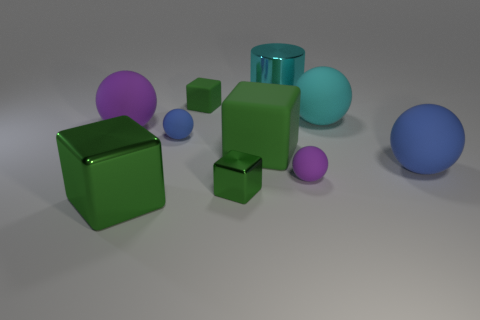Does the blue matte sphere that is left of the large cyan rubber ball have the same size as the cyan object on the right side of the cyan shiny cylinder? The two objects you're referring to are indeed distinct in size. The blue matte sphere to the left of the large cyan rubber ball is smaller when compared to the cyan object that is on the right side of the shiny cyan cylinder. 